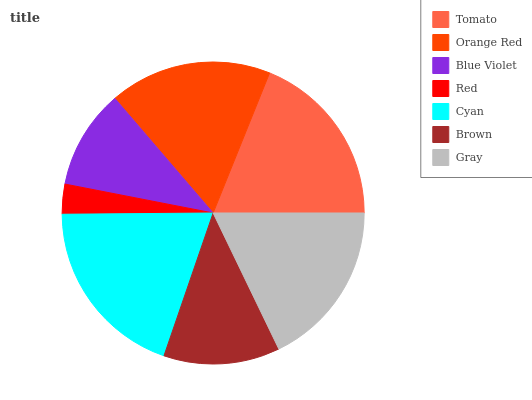Is Red the minimum?
Answer yes or no. Yes. Is Cyan the maximum?
Answer yes or no. Yes. Is Orange Red the minimum?
Answer yes or no. No. Is Orange Red the maximum?
Answer yes or no. No. Is Tomato greater than Orange Red?
Answer yes or no. Yes. Is Orange Red less than Tomato?
Answer yes or no. Yes. Is Orange Red greater than Tomato?
Answer yes or no. No. Is Tomato less than Orange Red?
Answer yes or no. No. Is Orange Red the high median?
Answer yes or no. Yes. Is Orange Red the low median?
Answer yes or no. Yes. Is Cyan the high median?
Answer yes or no. No. Is Red the low median?
Answer yes or no. No. 